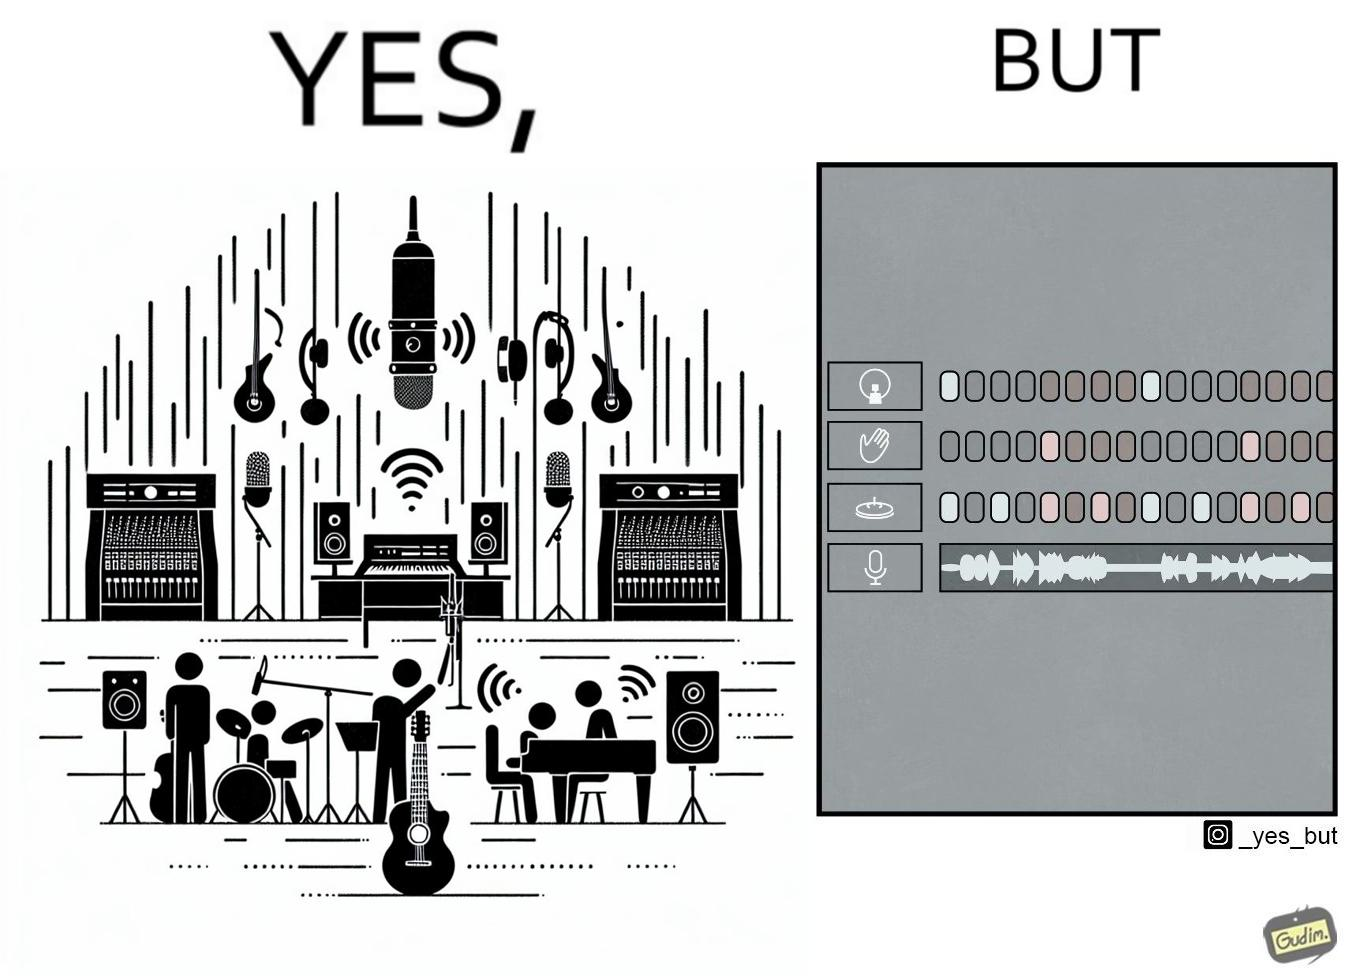Is this a satirical image? Yes, this image is satirical. 